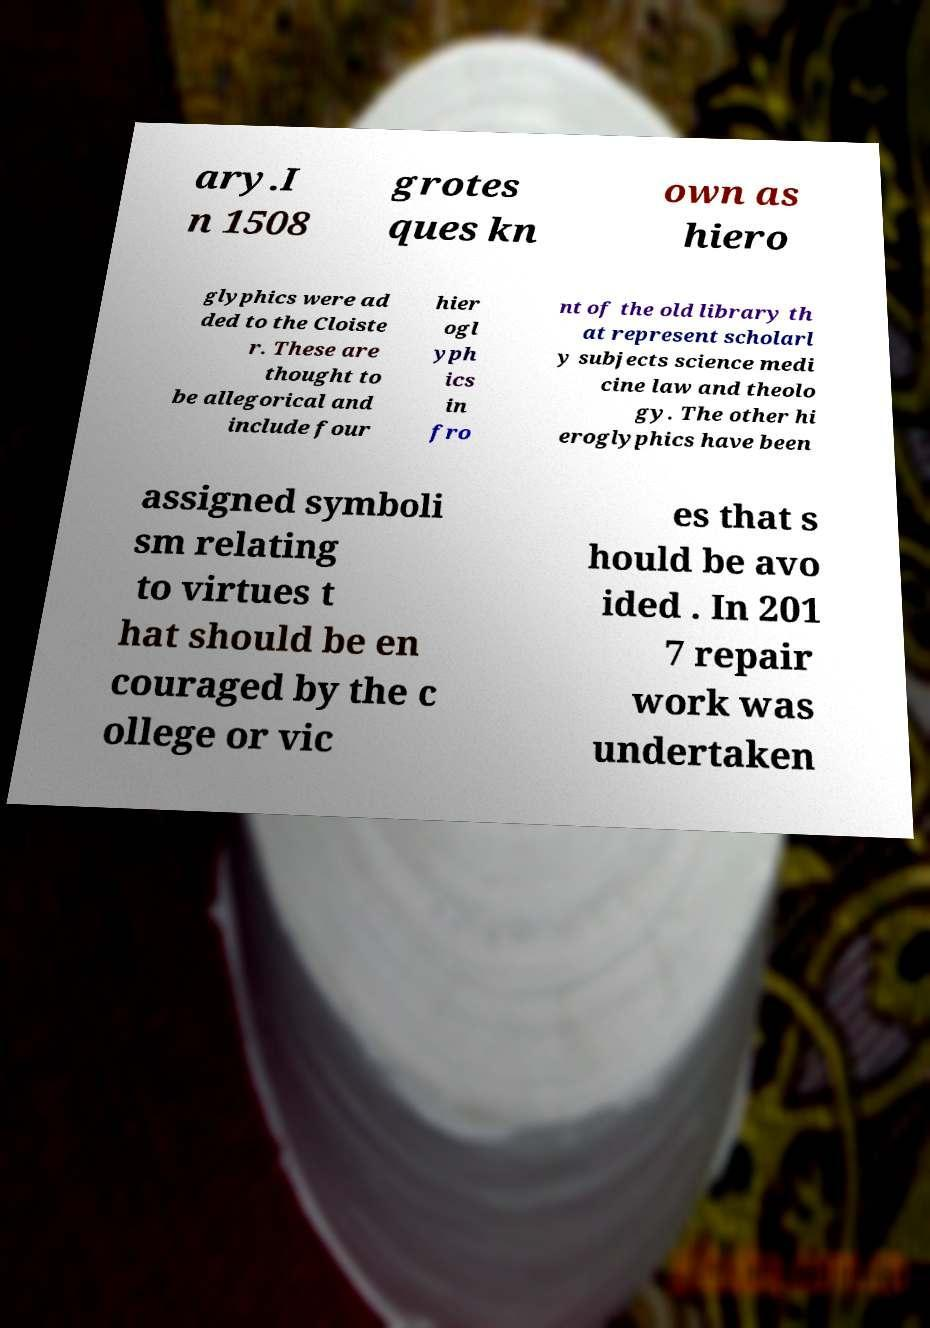I need the written content from this picture converted into text. Can you do that? ary.I n 1508 grotes ques kn own as hiero glyphics were ad ded to the Cloiste r. These are thought to be allegorical and include four hier ogl yph ics in fro nt of the old library th at represent scholarl y subjects science medi cine law and theolo gy. The other hi eroglyphics have been assigned symboli sm relating to virtues t hat should be en couraged by the c ollege or vic es that s hould be avo ided . In 201 7 repair work was undertaken 